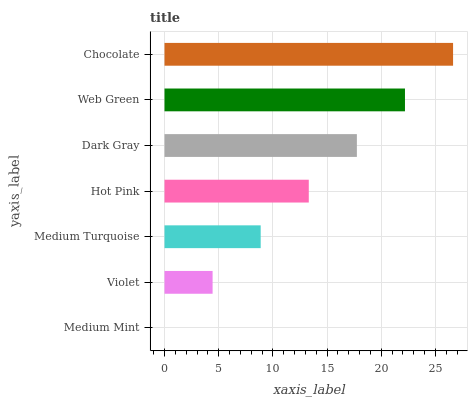Is Medium Mint the minimum?
Answer yes or no. Yes. Is Chocolate the maximum?
Answer yes or no. Yes. Is Violet the minimum?
Answer yes or no. No. Is Violet the maximum?
Answer yes or no. No. Is Violet greater than Medium Mint?
Answer yes or no. Yes. Is Medium Mint less than Violet?
Answer yes or no. Yes. Is Medium Mint greater than Violet?
Answer yes or no. No. Is Violet less than Medium Mint?
Answer yes or no. No. Is Hot Pink the high median?
Answer yes or no. Yes. Is Hot Pink the low median?
Answer yes or no. Yes. Is Violet the high median?
Answer yes or no. No. Is Medium Mint the low median?
Answer yes or no. No. 